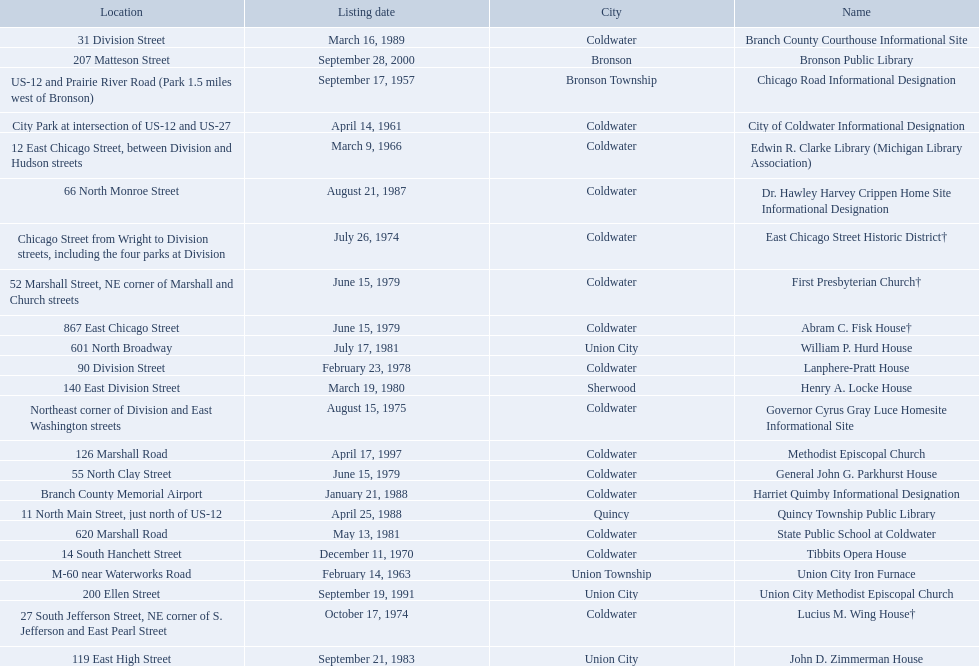In branch co. mi what historic sites are located on a near a highway? Chicago Road Informational Designation, City of Coldwater Informational Designation, Quincy Township Public Library, Union City Iron Furnace. Of the historic sites ins branch co. near highways, which ones are near only us highways? Chicago Road Informational Designation, City of Coldwater Informational Designation, Quincy Township Public Library. Which historical sites in branch co. are near only us highways and are not a building? Chicago Road Informational Designation, City of Coldwater Informational Designation. Which non-building historical sites in branch county near a us highways is closest to bronson? Chicago Road Informational Designation. 